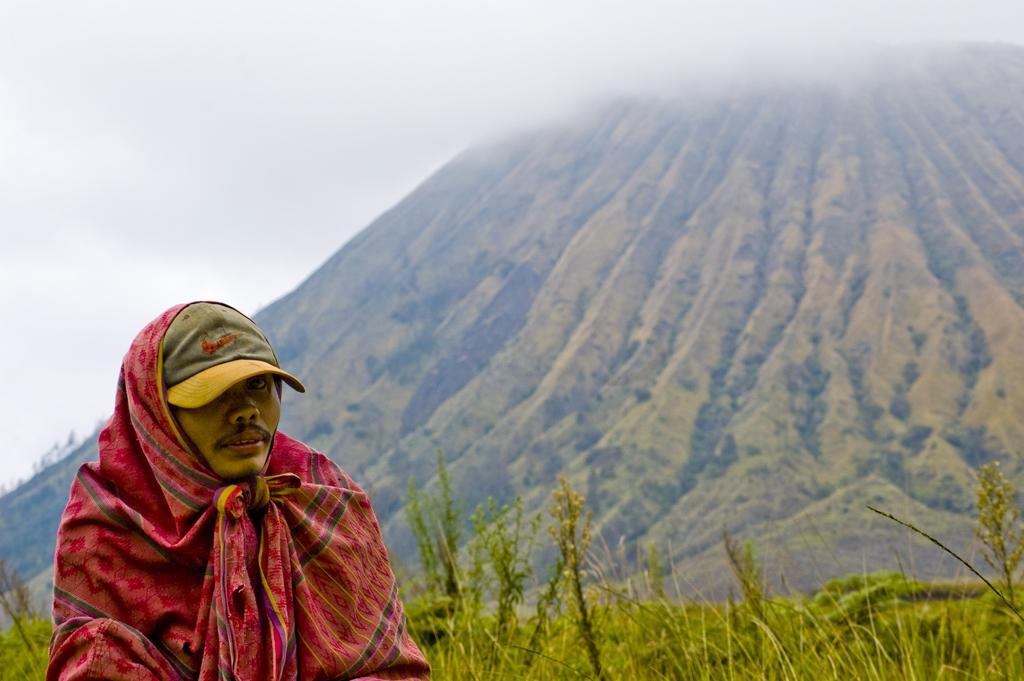Who is present in the image? There is a man in the image. What is the man wearing on his head? The man is wearing a cap. What type of clothing is the man wearing? The man is wearing cloth. What can be seen in the background of the image? There is a mountain, grass, and the sky visible in the background of the image. What type of wine is the man holding in the image? There is no wine present in the image; the man is not holding any wine. 